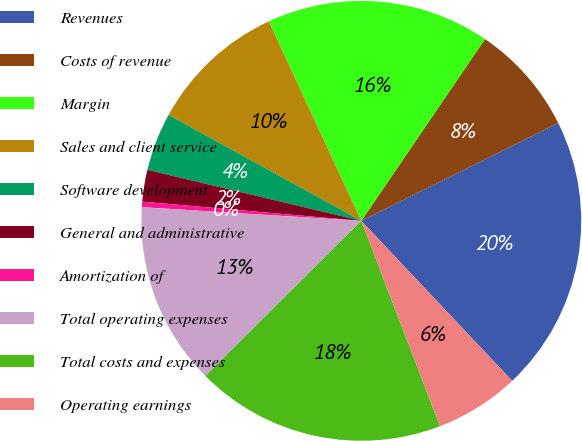Convert chart to OTSL. <chart><loc_0><loc_0><loc_500><loc_500><pie_chart><fcel>Revenues<fcel>Costs of revenue<fcel>Margin<fcel>Sales and client service<fcel>Software development<fcel>General and administrative<fcel>Amortization of<fcel>Total operating expenses<fcel>Total costs and expenses<fcel>Operating earnings<nl><fcel>20.3%<fcel>8.15%<fcel>16.42%<fcel>10.09%<fcel>4.27%<fcel>2.33%<fcel>0.4%<fcel>13.45%<fcel>18.36%<fcel>6.21%<nl></chart> 